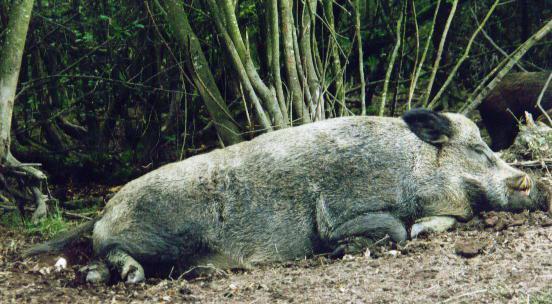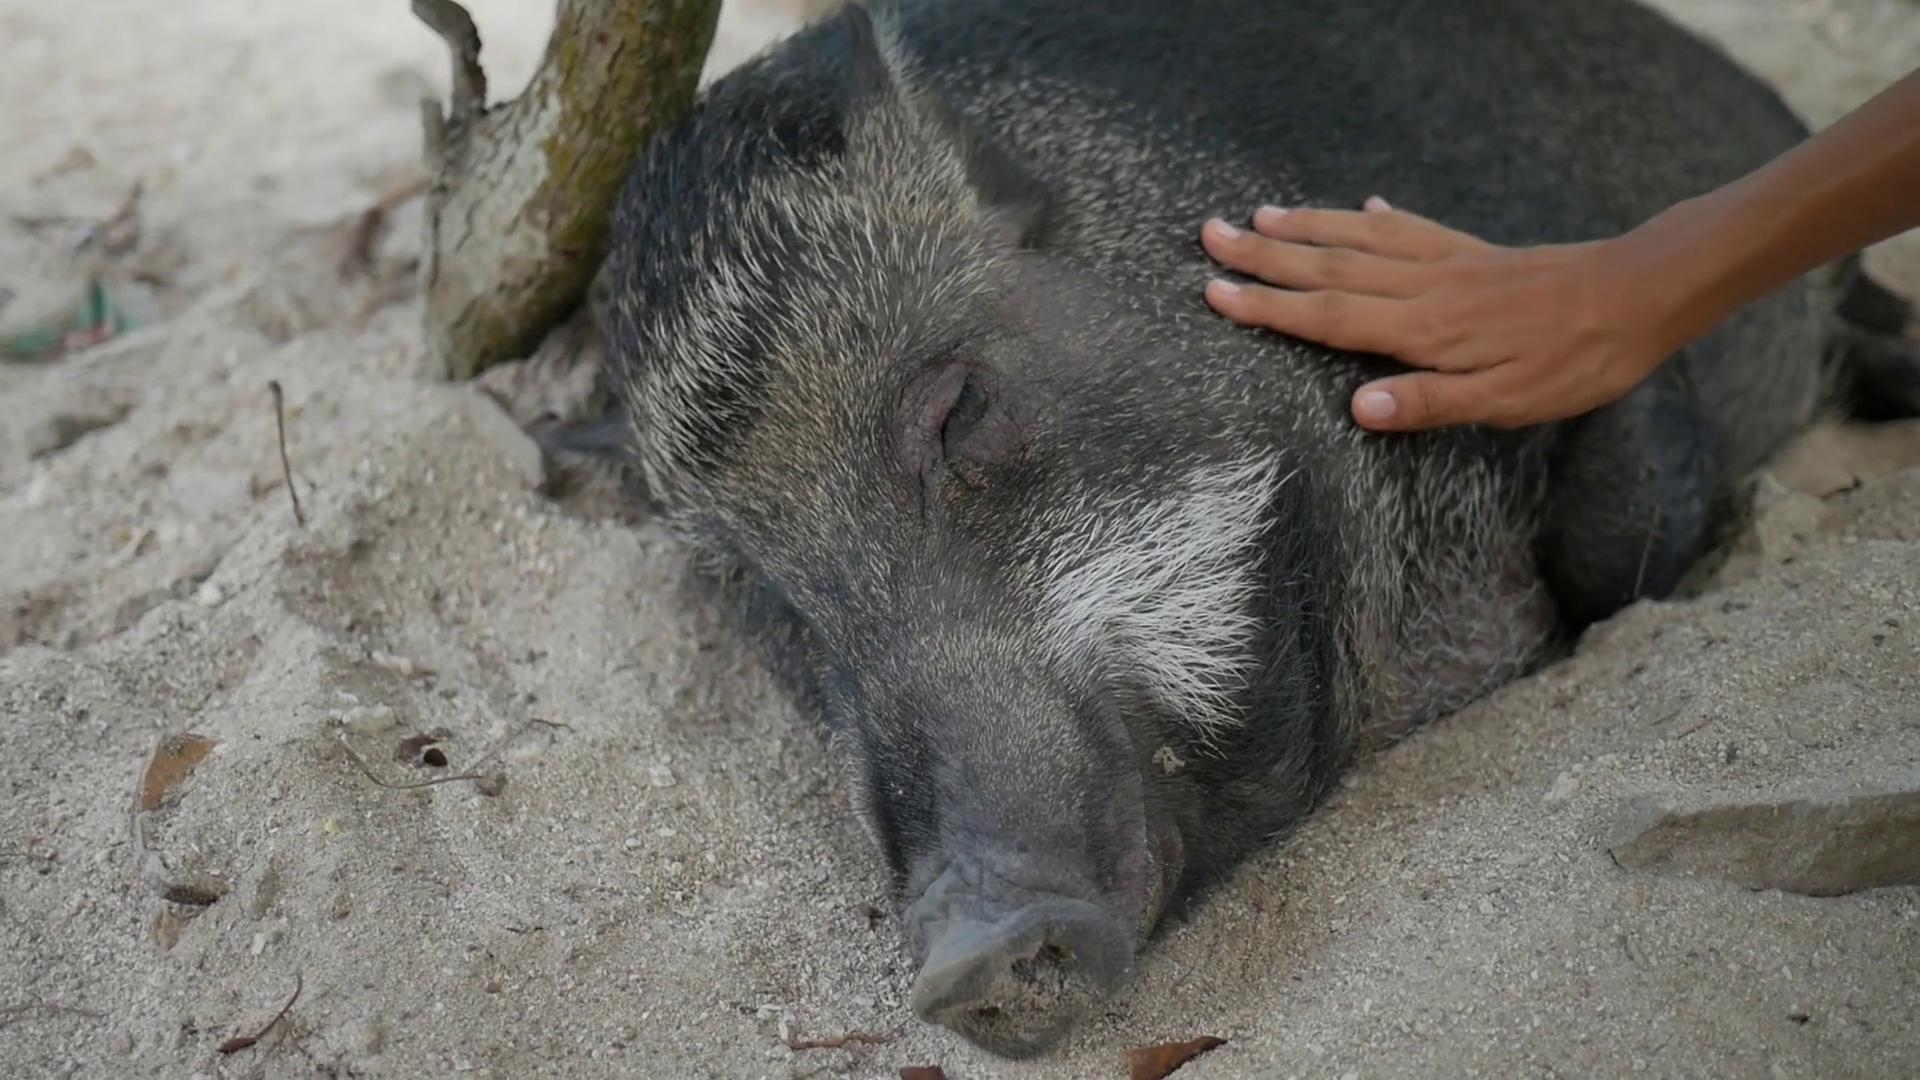The first image is the image on the left, the second image is the image on the right. Given the left and right images, does the statement "All pigs are in sleeping poses, and at least one pig is a baby with distinctive stripes." hold true? Answer yes or no. No. The first image is the image on the left, the second image is the image on the right. For the images displayed, is the sentence "There are two hogs in the pair of images." factually correct? Answer yes or no. Yes. 